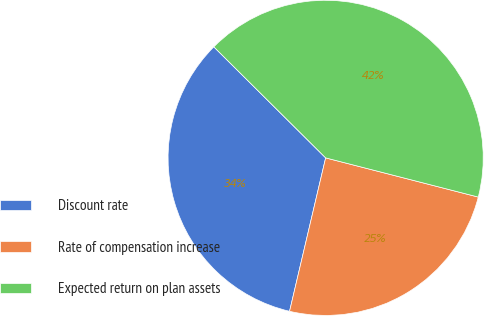Convert chart. <chart><loc_0><loc_0><loc_500><loc_500><pie_chart><fcel>Discount rate<fcel>Rate of compensation increase<fcel>Expected return on plan assets<nl><fcel>33.77%<fcel>24.68%<fcel>41.56%<nl></chart> 